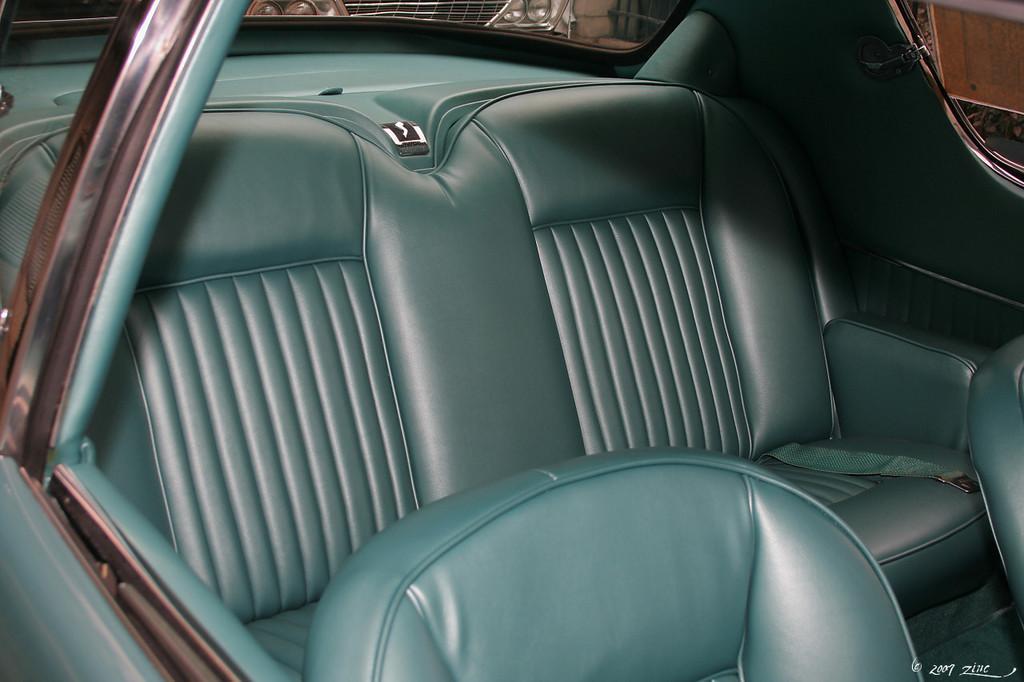In one or two sentences, can you explain what this image depicts? In this image there are some interiors of a car. There are cars in the background. 